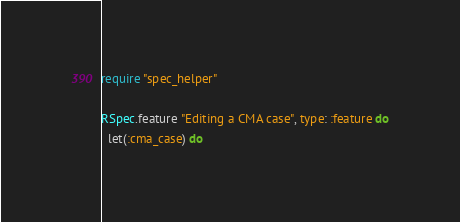<code> <loc_0><loc_0><loc_500><loc_500><_Ruby_>require "spec_helper"

RSpec.feature "Editing a CMA case", type: :feature do
  let(:cma_case) do</code> 